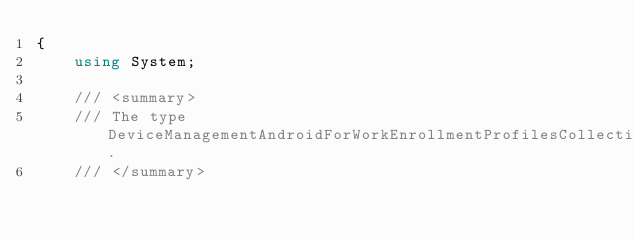<code> <loc_0><loc_0><loc_500><loc_500><_C#_>{
    using System;

    /// <summary>
    /// The type DeviceManagementAndroidForWorkEnrollmentProfilesCollectionPage.
    /// </summary></code> 